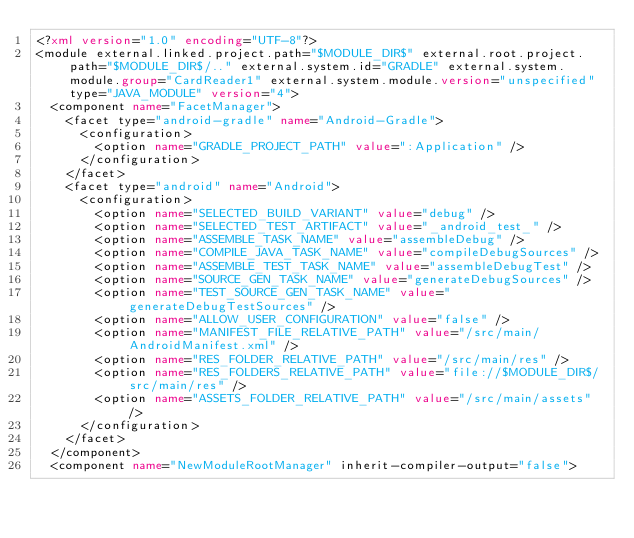Convert code to text. <code><loc_0><loc_0><loc_500><loc_500><_XML_><?xml version="1.0" encoding="UTF-8"?>
<module external.linked.project.path="$MODULE_DIR$" external.root.project.path="$MODULE_DIR$/.." external.system.id="GRADLE" external.system.module.group="CardReader1" external.system.module.version="unspecified" type="JAVA_MODULE" version="4">
  <component name="FacetManager">
    <facet type="android-gradle" name="Android-Gradle">
      <configuration>
        <option name="GRADLE_PROJECT_PATH" value=":Application" />
      </configuration>
    </facet>
    <facet type="android" name="Android">
      <configuration>
        <option name="SELECTED_BUILD_VARIANT" value="debug" />
        <option name="SELECTED_TEST_ARTIFACT" value="_android_test_" />
        <option name="ASSEMBLE_TASK_NAME" value="assembleDebug" />
        <option name="COMPILE_JAVA_TASK_NAME" value="compileDebugSources" />
        <option name="ASSEMBLE_TEST_TASK_NAME" value="assembleDebugTest" />
        <option name="SOURCE_GEN_TASK_NAME" value="generateDebugSources" />
        <option name="TEST_SOURCE_GEN_TASK_NAME" value="generateDebugTestSources" />
        <option name="ALLOW_USER_CONFIGURATION" value="false" />
        <option name="MANIFEST_FILE_RELATIVE_PATH" value="/src/main/AndroidManifest.xml" />
        <option name="RES_FOLDER_RELATIVE_PATH" value="/src/main/res" />
        <option name="RES_FOLDERS_RELATIVE_PATH" value="file://$MODULE_DIR$/src/main/res" />
        <option name="ASSETS_FOLDER_RELATIVE_PATH" value="/src/main/assets" />
      </configuration>
    </facet>
  </component>
  <component name="NewModuleRootManager" inherit-compiler-output="false"></code> 